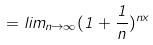<formula> <loc_0><loc_0><loc_500><loc_500>= l i m _ { n \rightarrow \infty } ( 1 + \frac { 1 } { n } ) ^ { n x }</formula> 